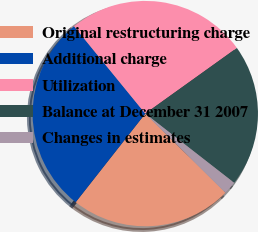<chart> <loc_0><loc_0><loc_500><loc_500><pie_chart><fcel>Original restructuring charge<fcel>Additional charge<fcel>Utilization<fcel>Balance at December 31 2007<fcel>Changes in estimates<nl><fcel>23.21%<fcel>28.51%<fcel>26.0%<fcel>20.43%<fcel>1.86%<nl></chart> 